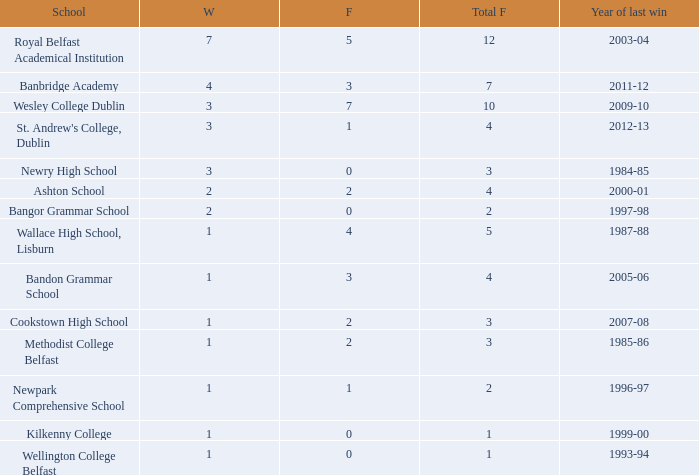How many times was banbridge academy the winner? 1.0. 